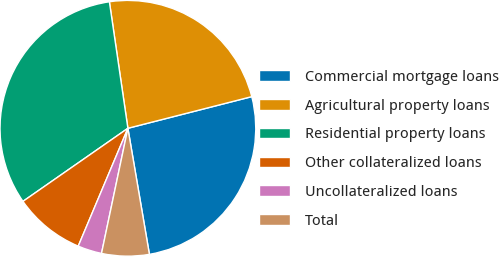Convert chart. <chart><loc_0><loc_0><loc_500><loc_500><pie_chart><fcel>Commercial mortgage loans<fcel>Agricultural property loans<fcel>Residential property loans<fcel>Other collateralized loans<fcel>Uncollateralized loans<fcel>Total<nl><fcel>26.29%<fcel>23.33%<fcel>32.37%<fcel>8.97%<fcel>3.04%<fcel>6.0%<nl></chart> 